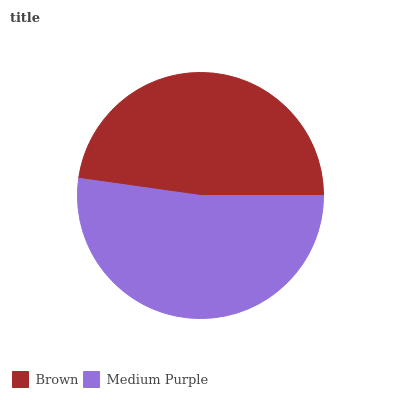Is Brown the minimum?
Answer yes or no. Yes. Is Medium Purple the maximum?
Answer yes or no. Yes. Is Medium Purple the minimum?
Answer yes or no. No. Is Medium Purple greater than Brown?
Answer yes or no. Yes. Is Brown less than Medium Purple?
Answer yes or no. Yes. Is Brown greater than Medium Purple?
Answer yes or no. No. Is Medium Purple less than Brown?
Answer yes or no. No. Is Medium Purple the high median?
Answer yes or no. Yes. Is Brown the low median?
Answer yes or no. Yes. Is Brown the high median?
Answer yes or no. No. Is Medium Purple the low median?
Answer yes or no. No. 